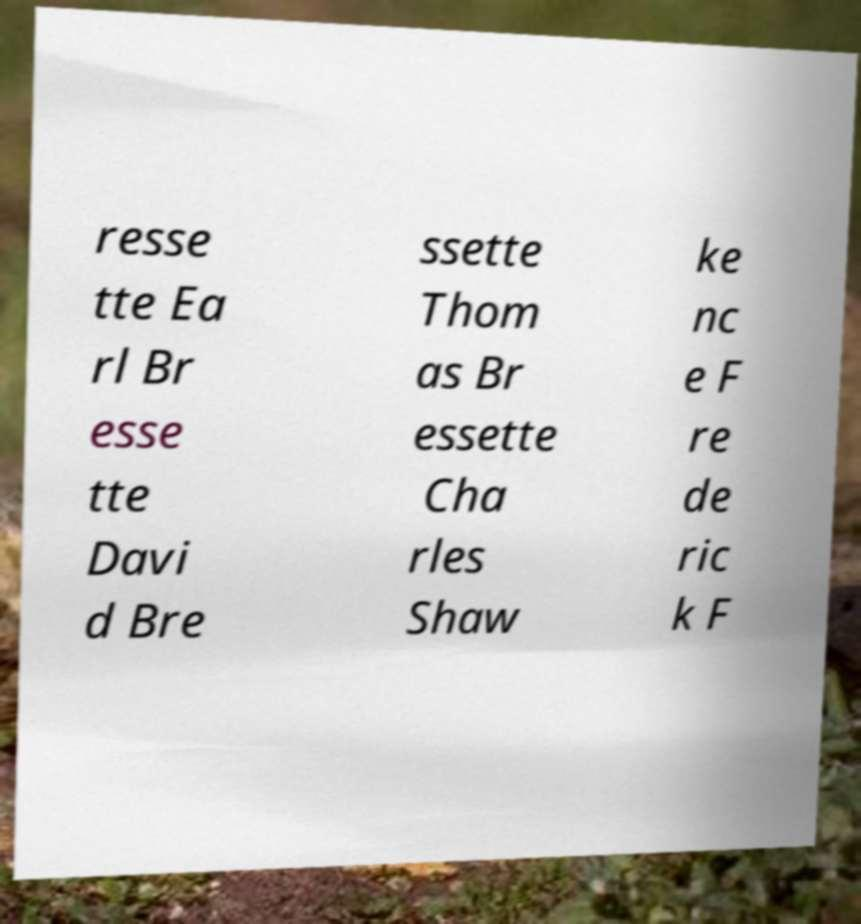Please identify and transcribe the text found in this image. resse tte Ea rl Br esse tte Davi d Bre ssette Thom as Br essette Cha rles Shaw ke nc e F re de ric k F 